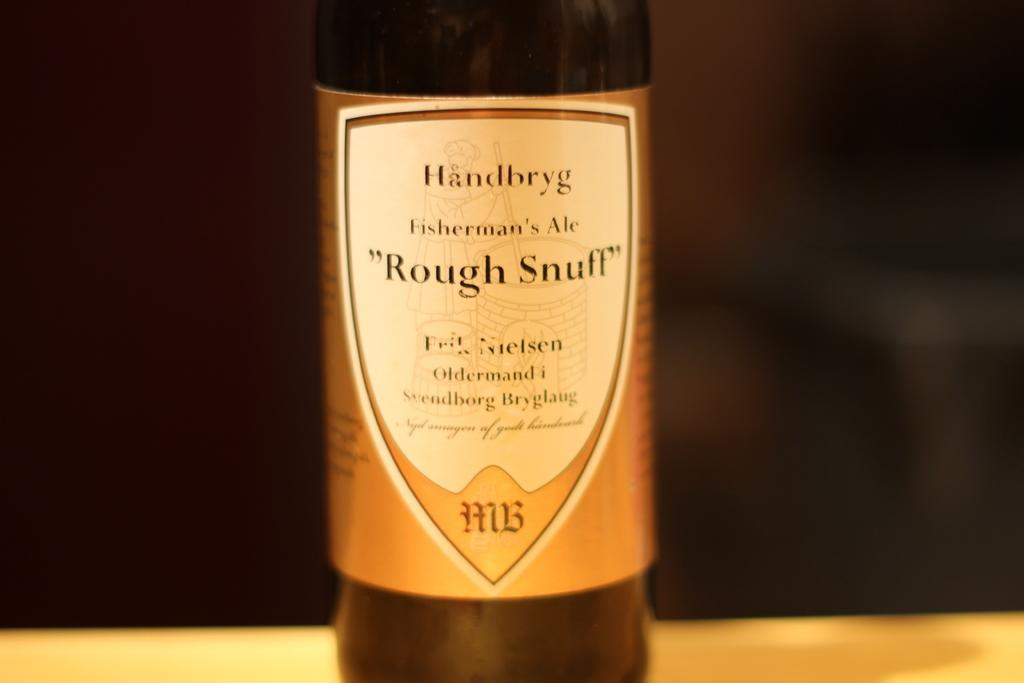<image>
Write a terse but informative summary of the picture. a bottle of handbryg fisherman's ale "rough snuff" 